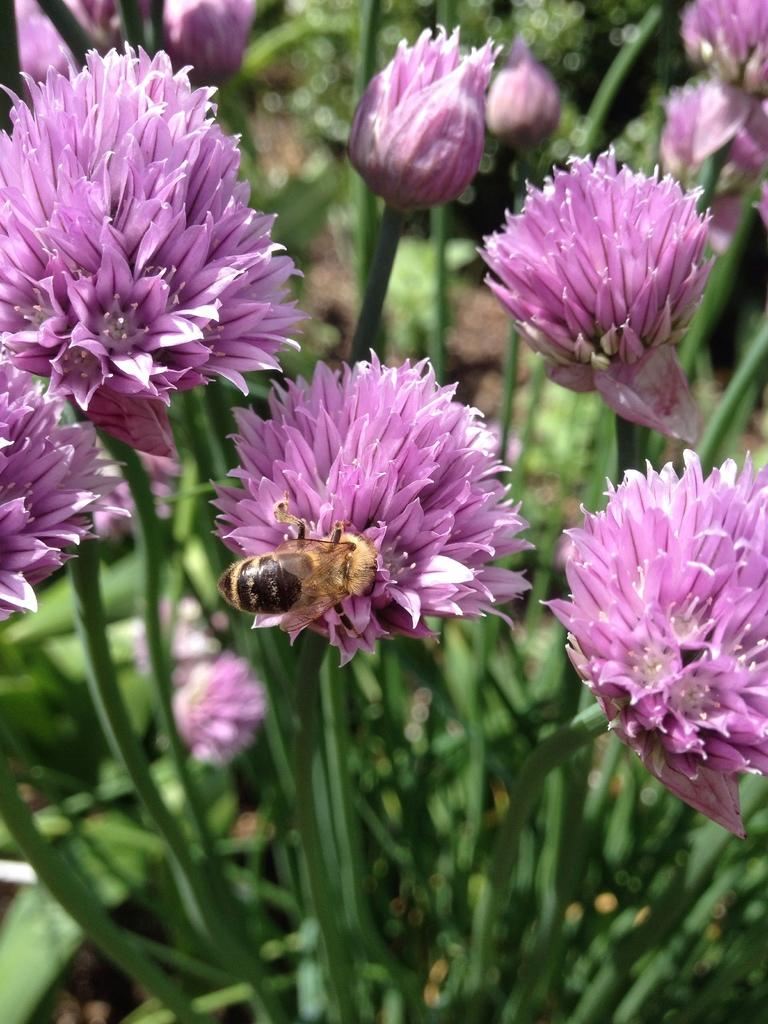What type of living organisms can be seen in the image? There are many plants in the image. What can be found on the plants in the image? There are flowers on the plants. Is there any other living organism present in the image? Yes, there is an insect on one of the flowers. What type of cough medicine is visible in the image? There is no cough medicine present in the image; it features plants, flowers, and an insect. 